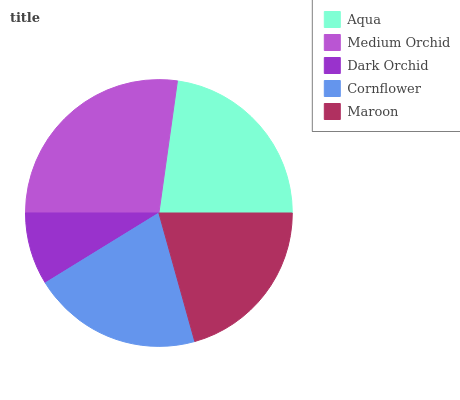Is Dark Orchid the minimum?
Answer yes or no. Yes. Is Medium Orchid the maximum?
Answer yes or no. Yes. Is Medium Orchid the minimum?
Answer yes or no. No. Is Dark Orchid the maximum?
Answer yes or no. No. Is Medium Orchid greater than Dark Orchid?
Answer yes or no. Yes. Is Dark Orchid less than Medium Orchid?
Answer yes or no. Yes. Is Dark Orchid greater than Medium Orchid?
Answer yes or no. No. Is Medium Orchid less than Dark Orchid?
Answer yes or no. No. Is Maroon the high median?
Answer yes or no. Yes. Is Maroon the low median?
Answer yes or no. Yes. Is Cornflower the high median?
Answer yes or no. No. Is Dark Orchid the low median?
Answer yes or no. No. 